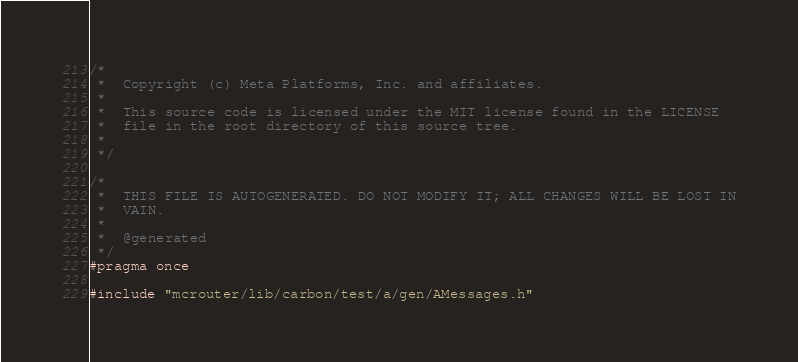Convert code to text. <code><loc_0><loc_0><loc_500><loc_500><_C_>/*
 *  Copyright (c) Meta Platforms, Inc. and affiliates.
 *
 *  This source code is licensed under the MIT license found in the LICENSE
 *  file in the root directory of this source tree.
 *
 */

/*
 *  THIS FILE IS AUTOGENERATED. DO NOT MODIFY IT; ALL CHANGES WILL BE LOST IN
 *  VAIN.
 *
 *  @generated
 */
#pragma once

#include "mcrouter/lib/carbon/test/a/gen/AMessages.h"
</code> 